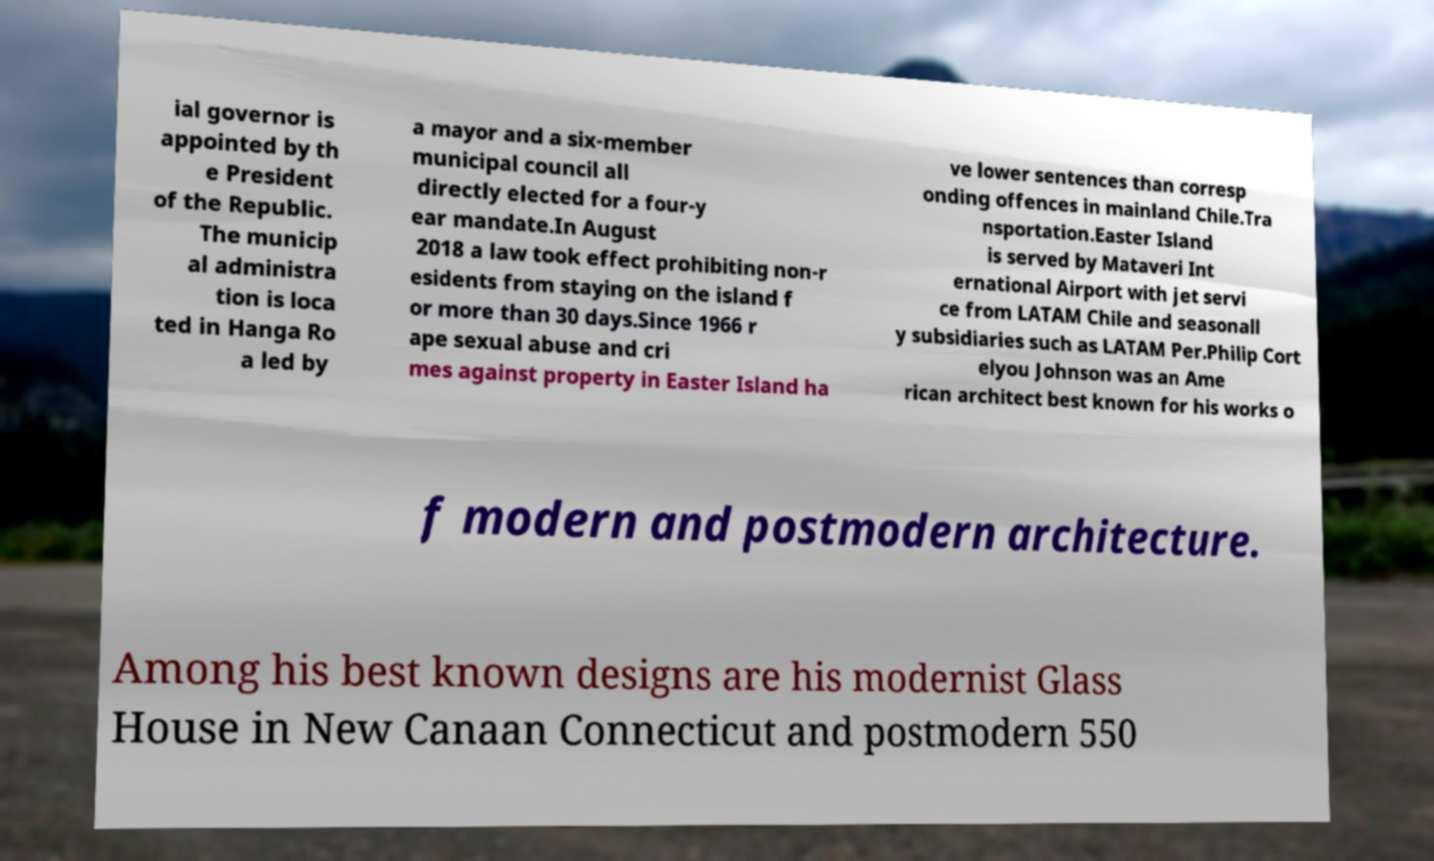There's text embedded in this image that I need extracted. Can you transcribe it verbatim? ial governor is appointed by th e President of the Republic. The municip al administra tion is loca ted in Hanga Ro a led by a mayor and a six-member municipal council all directly elected for a four-y ear mandate.In August 2018 a law took effect prohibiting non-r esidents from staying on the island f or more than 30 days.Since 1966 r ape sexual abuse and cri mes against property in Easter Island ha ve lower sentences than corresp onding offences in mainland Chile.Tra nsportation.Easter Island is served by Mataveri Int ernational Airport with jet servi ce from LATAM Chile and seasonall y subsidiaries such as LATAM Per.Philip Cort elyou Johnson was an Ame rican architect best known for his works o f modern and postmodern architecture. Among his best known designs are his modernist Glass House in New Canaan Connecticut and postmodern 550 